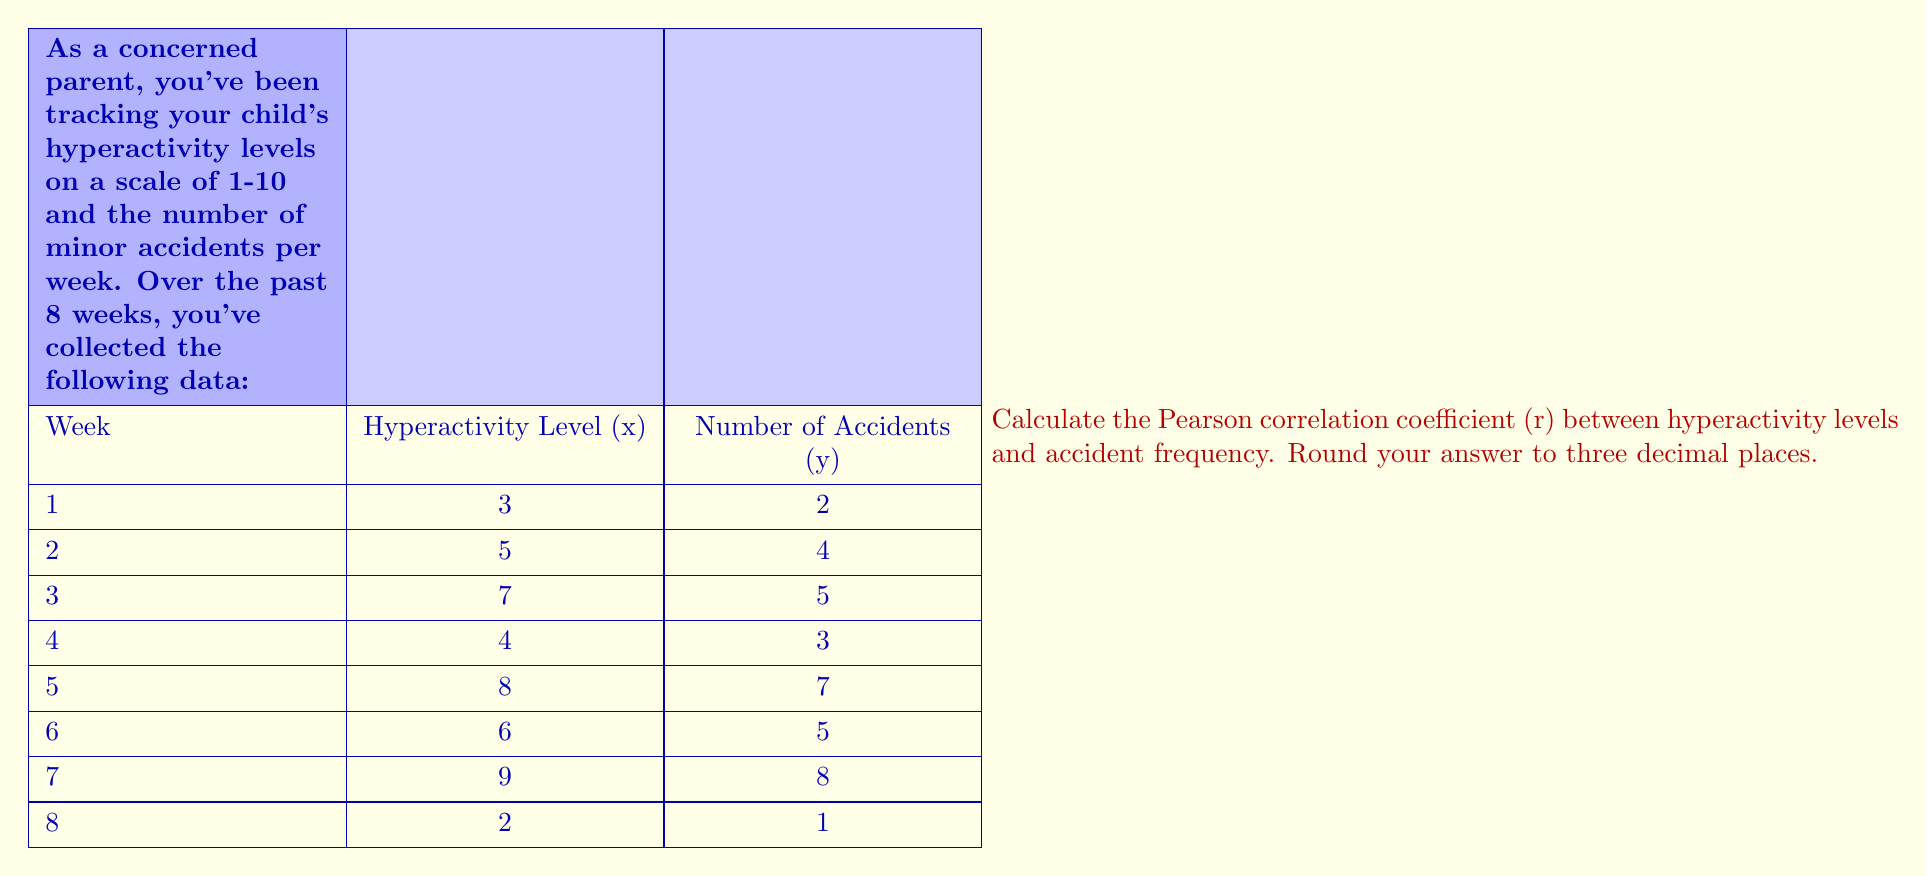Give your solution to this math problem. To calculate the Pearson correlation coefficient (r), we'll use the formula:

$$ r = \frac{n\sum xy - (\sum x)(\sum y)}{\sqrt{[n\sum x^2 - (\sum x)^2][n\sum y^2 - (\sum y)^2]}} $$

Where:
n = number of data points
x = hyperactivity level
y = number of accidents

Step 1: Calculate the necessary sums:
$\sum x = 44$
$\sum y = 35$
$\sum xy = 251$
$\sum x^2 = 278$
$\sum y^2 = 179$

Step 2: Calculate $n\sum xy$:
$n\sum xy = 8 \times 251 = 2008$

Step 3: Calculate $(\sum x)(\sum y)$:
$(\sum x)(\sum y) = 44 \times 35 = 1540$

Step 4: Calculate $n\sum x^2$:
$n\sum x^2 = 8 \times 278 = 2224$

Step 5: Calculate $(\sum x)^2$:
$(\sum x)^2 = 44^2 = 1936$

Step 6: Calculate $n\sum y^2$:
$n\sum y^2 = 8 \times 179 = 1432$

Step 7: Calculate $(\sum y)^2$:
$(\sum y)^2 = 35^2 = 1225$

Step 8: Plug values into the formula:

$$ r = \frac{2008 - 1540}{\sqrt{(2224 - 1936)(1432 - 1225)}} $$

$$ r = \frac{468}{\sqrt{288 \times 207}} $$

$$ r = \frac{468}{\sqrt{59616}} $$

$$ r = \frac{468}{244.16} $$

$$ r \approx 0.9174 $$

Round to three decimal places: r = 0.917
Answer: 0.917 